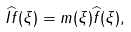Convert formula to latex. <formula><loc_0><loc_0><loc_500><loc_500>\widehat { I f } ( \xi ) = m ( \xi ) \widehat { f } ( \xi ) ,</formula> 